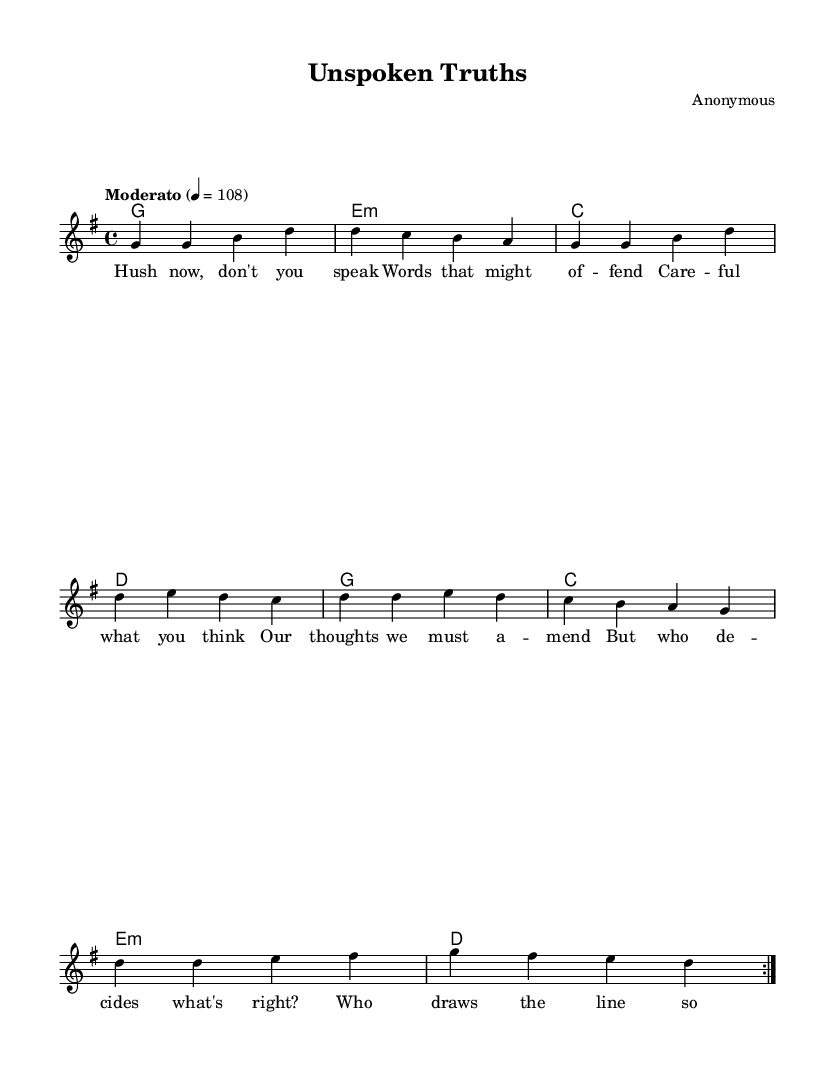What is the key signature of this music? The key signature is G major, which has one sharp (F#). This can be identified by looking at the key signature indicator at the beginning of the staff.
Answer: G major What is the time signature of this music? The time signature is 4/4, which signifies that there are four beats in each measure and the quarter note gets one beat. This can be seen at the beginning of the music sheet.
Answer: 4/4 What is the tempo marking for this piece? The tempo marking is "Moderato" with a metronome marking of 108 beats per minute, indicating a moderate speed. It is indicated at the beginning of the score, giving performers guidance on the pace.
Answer: Moderato, 108 How many measures are repeated in the melody? The melody has a repeat sign indicated with "volta 2," indicating that the section should be played twice. The music consists of two sections, each repeated.
Answer: 2 What themes are addressed in the song lyrics? The song lyrics critique censorship and the limitations on free expression, questioning authority and societal norms regarding what is acceptable to express and share. The use of phrases such as "unspoken truths" highlights this theme.
Answer: Censorship and societal norms What type of harmony is primarily used in this piece? The harmony consists mainly of triadic chords typical of pop music, which are played in a straightforward pattern in the measure structure. The chords follow a simple progression that supports the melody effectively.
Answer: Triadic Who is the composer of this piece? The composer is listed as "Anonymous," indicating that the creator of the piece has not been identified or chooses to remain unnamed. This can be found in the header section of the score.
Answer: Anonymous 